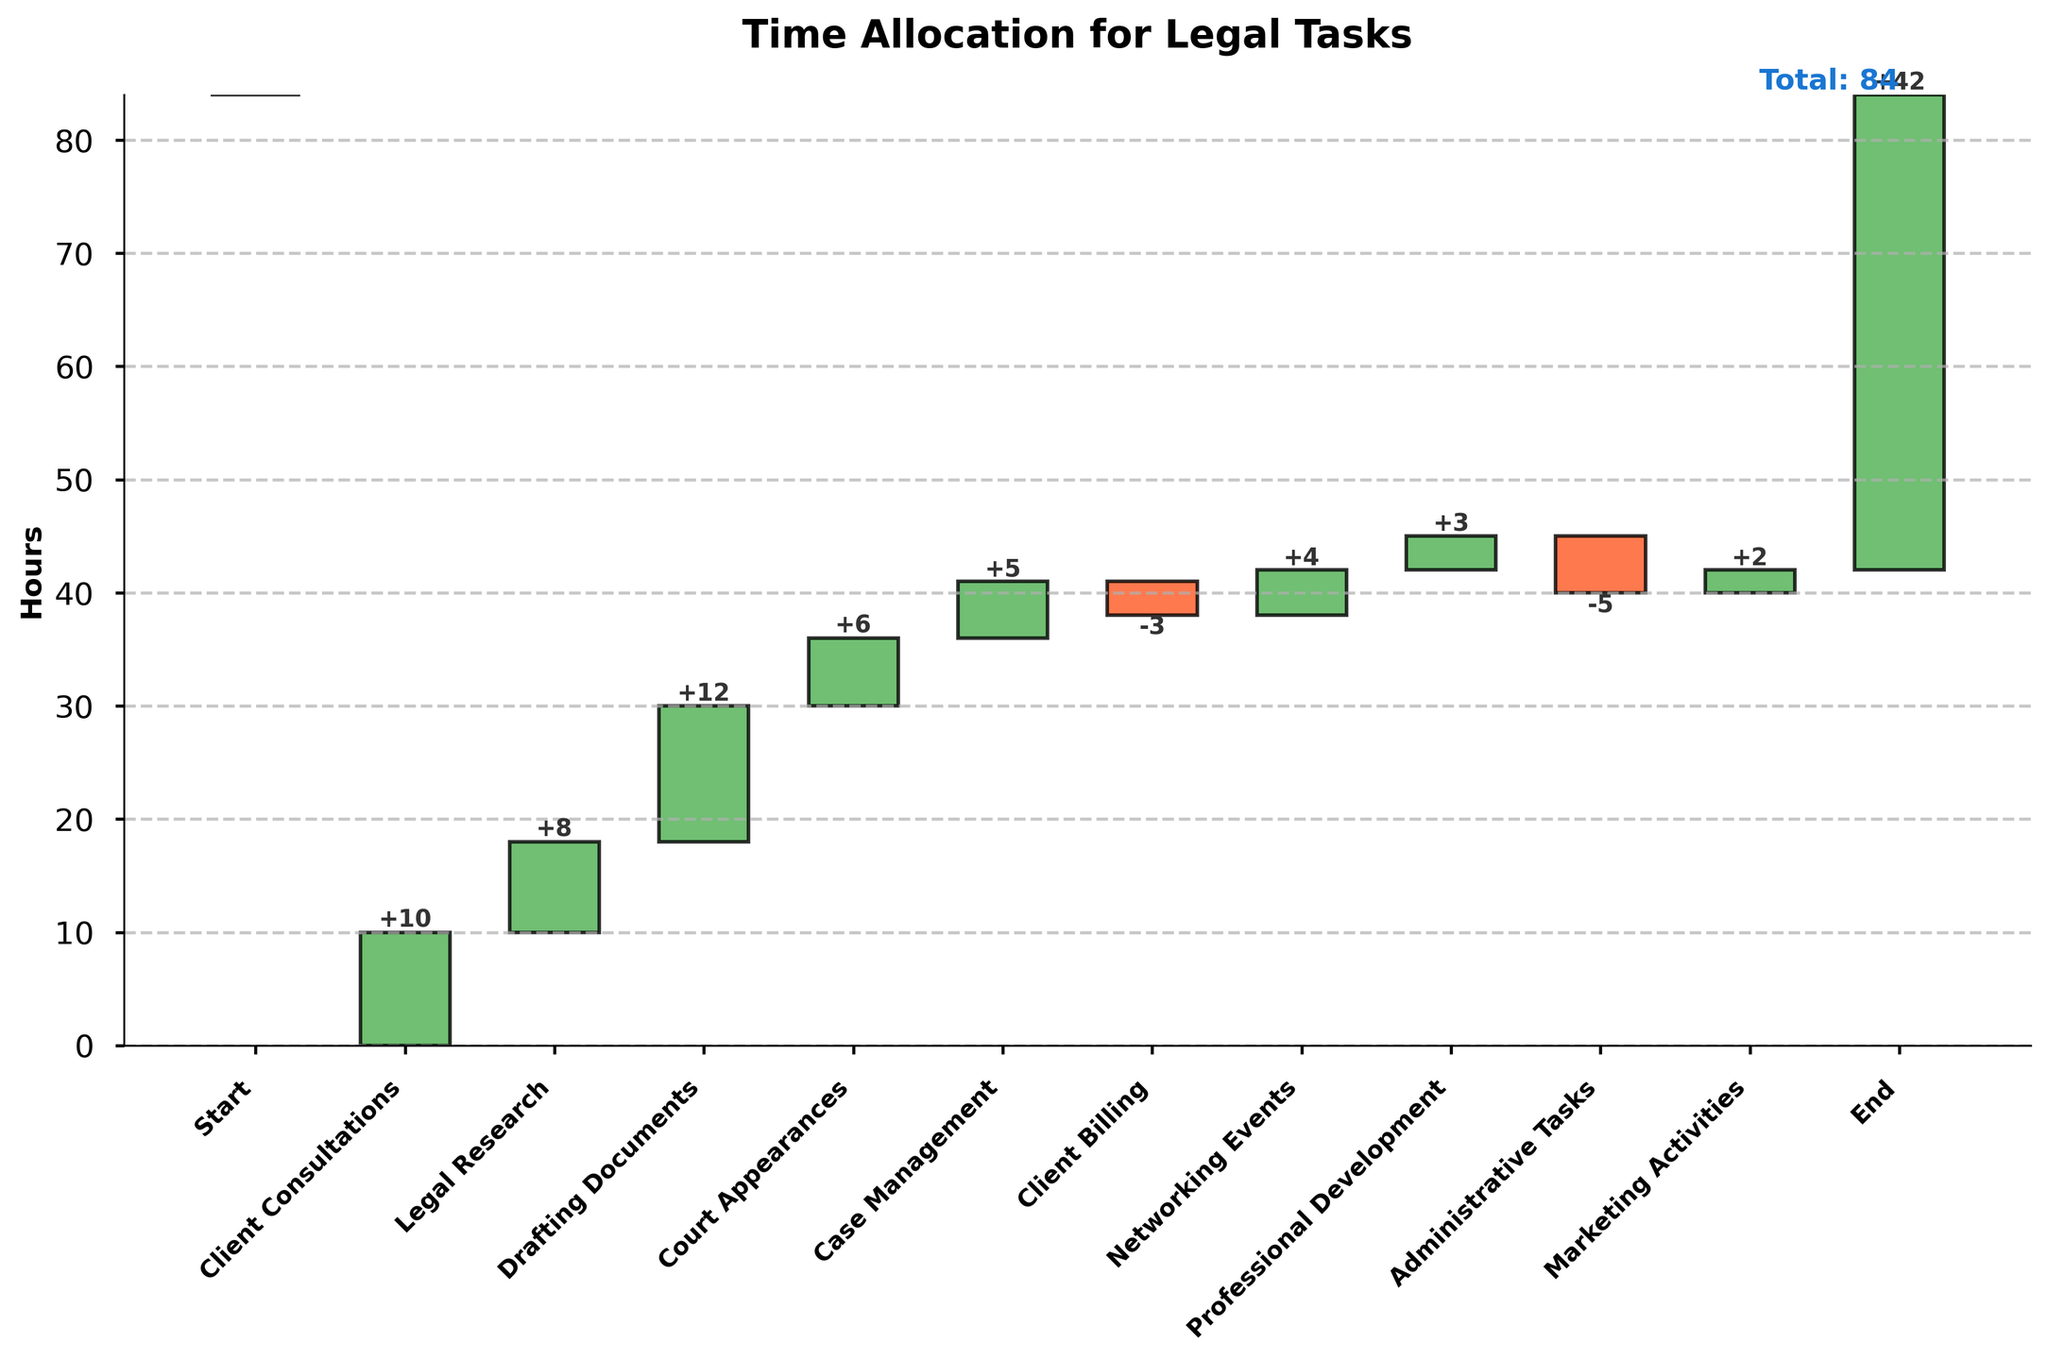What's the title of the figure? The title is located at the top of the chart. It gives a summary of what the chart is about.
Answer: Time Allocation for Legal Tasks How many tasks are listed in the chart, excluding the Start and End points? Exclude the 'Start' and 'End' tasks and count all the remaining tasks listed in the chart.
Answer: 9 Which task took the most time? Check the bar with the highest positive value. The 'Drafting Documents' bar is the highest above the baseline.
Answer: Drafting Documents How much time is spent on Client Consultations and Legal Research combined? Look at the values for 'Client Consultations' and 'Legal Research'. Add their values together (10 + 8).
Answer: 18 hours What is the net effect of Administrative Tasks on the total time? Find the bar for 'Administrative Tasks'. The net effect is negative, and it shows a reduction in hours (-5 hours).
Answer: -5 hours Is more time spent on Professional Development or Marketing Activities? Compare the values of the bars for 'Professional Development' and 'Marketing Activities'. 'Professional Development' (3) is greater than 'Marketing Activities' (2).
Answer: Professional Development What is the cumulative time at the end of Legal Research? Cumulative time up to and including 'Legal Research' is found by adding 'Client Consultations' and 'Legal Research' (0 + 10 + 8).
Answer: 18 hours Which activity reduced the total hours the most? Identify the bar with the largest negative value. 'Administrative Tasks' has the largest negative impact (-5 hours).
Answer: Administrative Tasks How much time, on net, is spent on activities that increase the total time? Sum all positive values ('Client Consultations', 'Legal Research', 'Drafting Documents', 'Court Appearances', 'Case Management', 'Networking Events', 'Professional Development', 'Marketing Activities') (10 + 8 + 12 + 6 + 5 + 4 + 3 + 2).
Answer: 50 hours If you only consider productive tasks like Client Consultations, Drafting Documents, and Court Appearances, how many hours are spent on these tasks? Sum the values for 'Client Consultations', 'Drafting Documents', and 'Court Appearances' (10 + 12 + 6).
Answer: 28 hours 